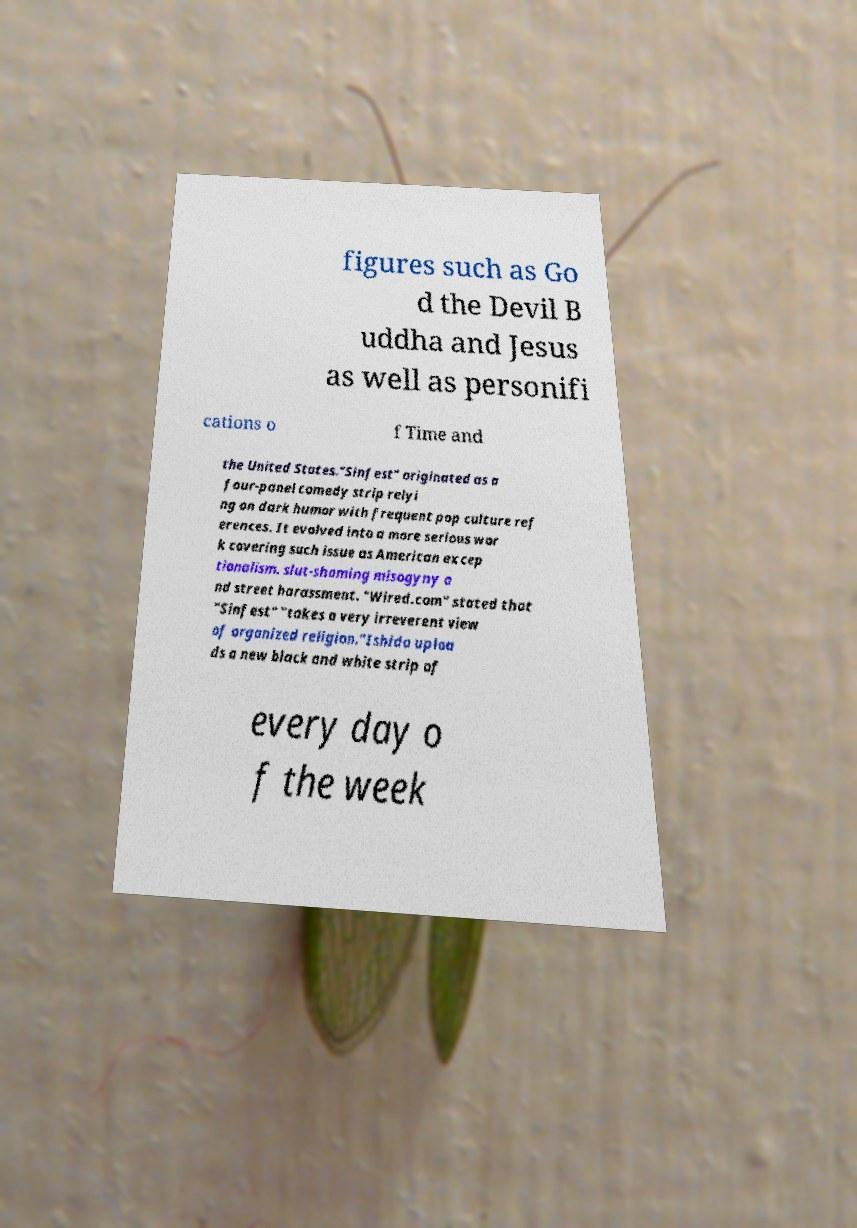Please identify and transcribe the text found in this image. figures such as Go d the Devil B uddha and Jesus as well as personifi cations o f Time and the United States."Sinfest" originated as a four-panel comedy strip relyi ng on dark humor with frequent pop culture ref erences. It evolved into a more serious wor k covering such issue as American excep tionalism. slut-shaming misogyny a nd street harassment. "Wired.com" stated that "Sinfest" "takes a very irreverent view of organized religion."Ishida uploa ds a new black and white strip of every day o f the week 